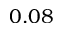Convert formula to latex. <formula><loc_0><loc_0><loc_500><loc_500>0 . 0 8</formula> 